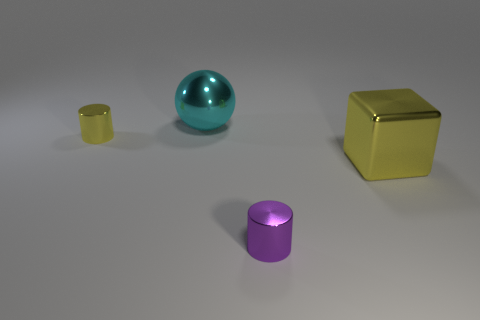Add 4 spheres. How many objects exist? 8 Subtract 1 cylinders. How many cylinders are left? 1 Add 3 matte things. How many matte things exist? 3 Subtract 0 blue balls. How many objects are left? 4 Subtract all yellow spheres. Subtract all cyan cylinders. How many spheres are left? 1 Subtract all green cylinders. How many blue blocks are left? 0 Subtract all red matte objects. Subtract all small shiny things. How many objects are left? 2 Add 4 tiny yellow metal things. How many tiny yellow metal things are left? 5 